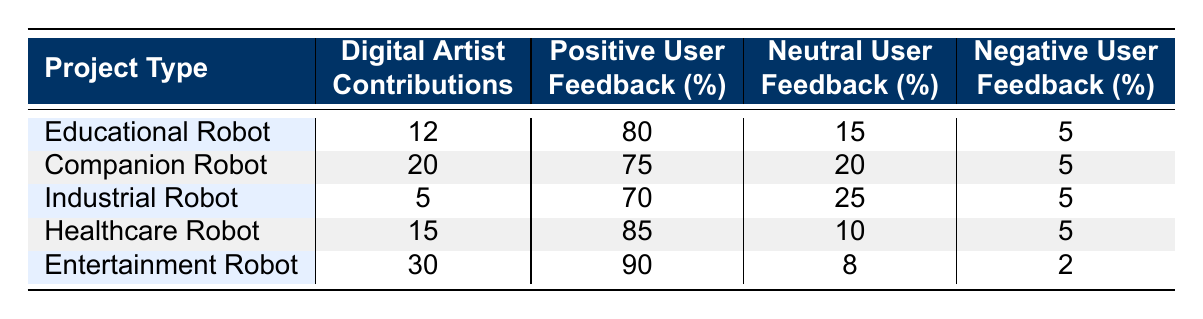What is the project type with the highest number of digital artist contributions? By examining the "Digital Artist Contributions" column, we see the numbers: Educational Robot (12), Companion Robot (20), Industrial Robot (5), Healthcare Robot (15), and Entertainment Robot (30). The highest value is 30 for the Entertainment Robot.
Answer: Entertainment Robot What percentage of user feedback for the Healthcare Robot was positive? Referring to the "Positive User Feedback (%)" column, the percentage for Healthcare Robot is 85.
Answer: 85 How many digital artist contributions were made for Companion and Healthcare Robots combined? The contributions for Companion Robot are 20 and for Healthcare Robot are 15. Summing these: 20 + 15 = 35.
Answer: 35 Is the positive user feedback for the Industrial Robot greater than 70%? The positive user feedback recorded for the Industrial Robot is 70%. Since 70% is not greater than 70%, the answer is no.
Answer: No What is the difference in positive user feedback between Entertainment and Educational Robots? The positive user feedback for Entertainment Robot is 90% and for Educational Robot is 80%. The difference is calculated as 90 - 80 = 10%.
Answer: 10 Which project type has the lowest user feedback rated neutral? Looking at the "Neutral User Feedback (%)" column, the values are 15 for Educational Robot, 20 for Companion Robot, 25 for Industrial Robot, 10 for Healthcare Robot, and 8 for Entertainment Robot. The lowest value is 8 for the Entertainment Robot.
Answer: Entertainment Robot What is the average percentage of neutral user feedback across all project types? To find the average, we sum the neutral user feedback percentages: 15 + 20 + 25 + 10 + 8 = 78. There are 5 project types, so the average is 78 / 5 = 15.6.
Answer: 15.6 Does the Companion Robot have a higher percentage of negative user feedback than the Entertainment Robot? The Companion Robot has a negative feedback percentage of 5, while the Entertainment Robot has a lower percentage of 2. Since 5 is greater than 2, the answer is yes.
Answer: Yes What total percentage of feedback for the Educational Robot is either positive or neutral? The positive feedback percentage for Educational Robot is 80% and neutral is 15%. Summing these gives 80 + 15 = 95%.
Answer: 95 